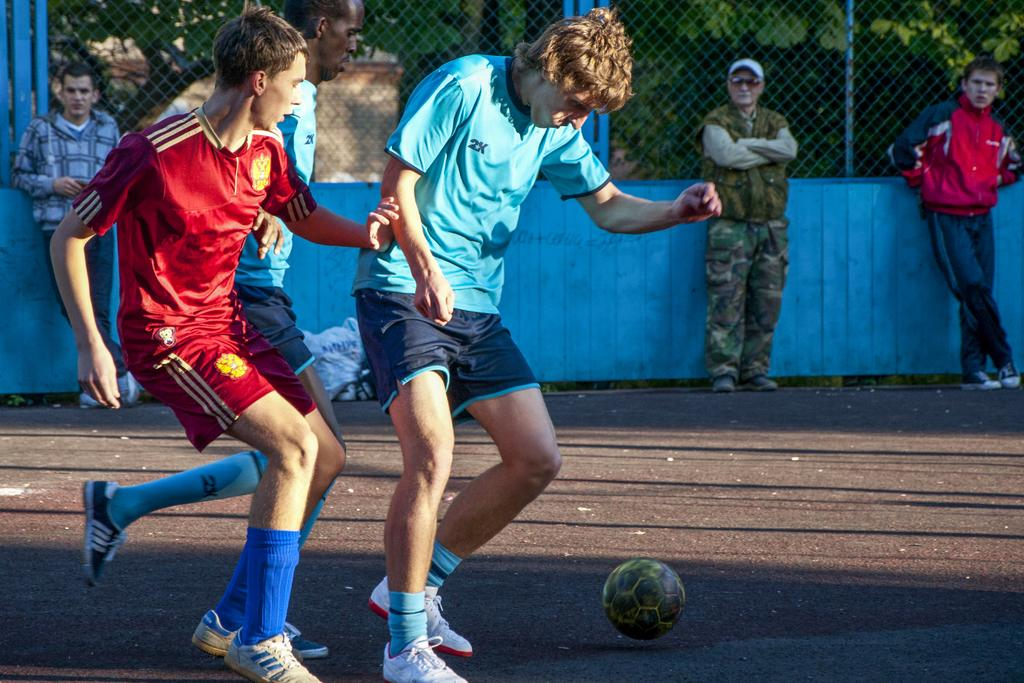How many people are in the image? There is a group of people in the image. What are some of the people doing in the image? Some people are playing a game in the image. What object is in front of the people? There is a ball in front of the people. What can be seen in the background of the image? There is a fence and trees in the background of the image. What type of grip does the laborer have on the feeling in the image? There is no laborer or feeling present in the image; it features a group of people playing a game with a ball. 